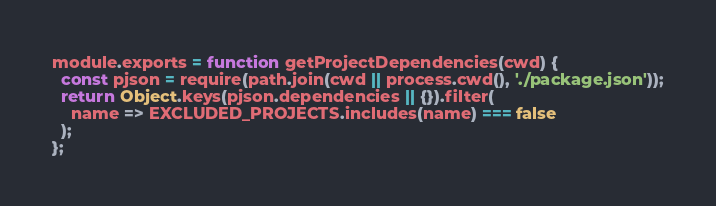<code> <loc_0><loc_0><loc_500><loc_500><_JavaScript_>module.exports = function getProjectDependencies(cwd) {
  const pjson = require(path.join(cwd || process.cwd(), './package.json'));
  return Object.keys(pjson.dependencies || {}).filter(
    name => EXCLUDED_PROJECTS.includes(name) === false
  );
};
</code> 